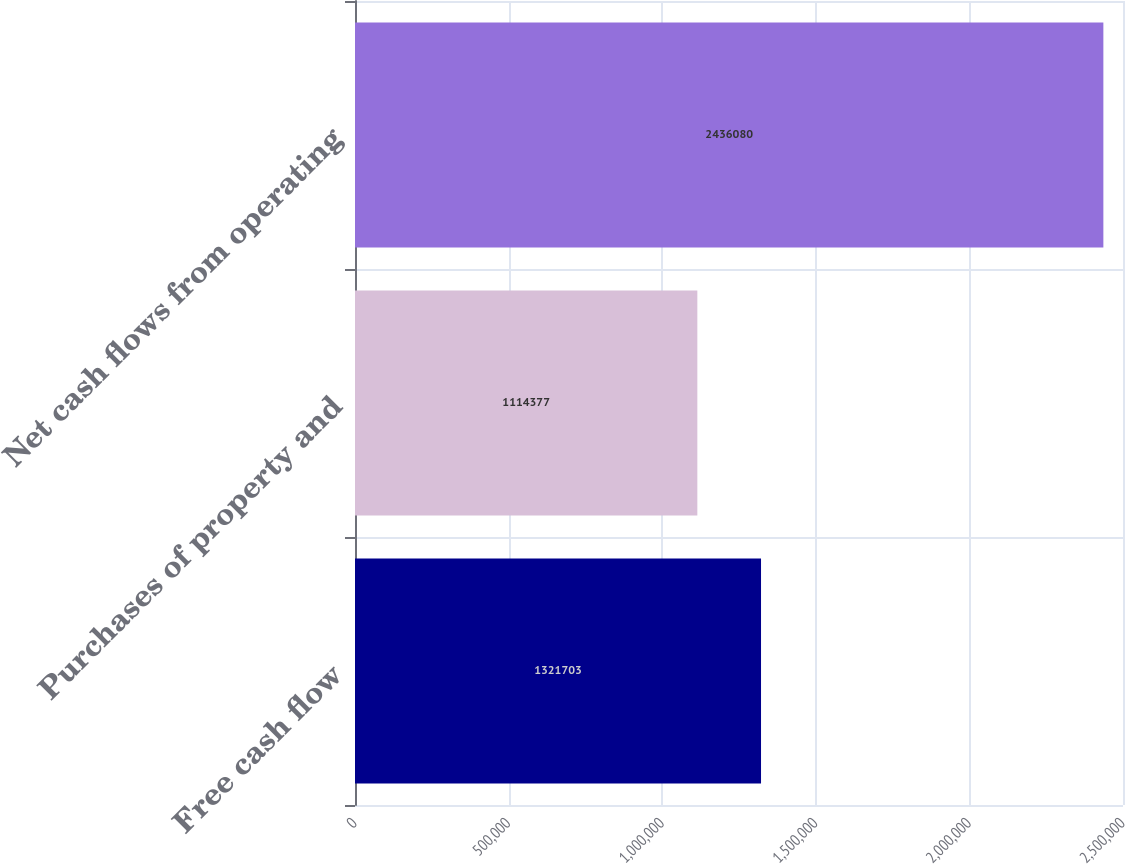Convert chart to OTSL. <chart><loc_0><loc_0><loc_500><loc_500><bar_chart><fcel>Free cash flow<fcel>Purchases of property and<fcel>Net cash flows from operating<nl><fcel>1.3217e+06<fcel>1.11438e+06<fcel>2.43608e+06<nl></chart> 